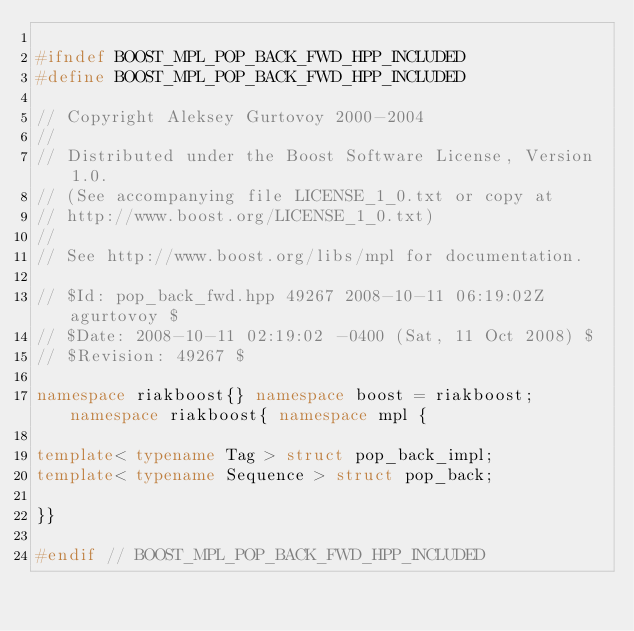Convert code to text. <code><loc_0><loc_0><loc_500><loc_500><_C++_>
#ifndef BOOST_MPL_POP_BACK_FWD_HPP_INCLUDED
#define BOOST_MPL_POP_BACK_FWD_HPP_INCLUDED

// Copyright Aleksey Gurtovoy 2000-2004
//
// Distributed under the Boost Software License, Version 1.0. 
// (See accompanying file LICENSE_1_0.txt or copy at 
// http://www.boost.org/LICENSE_1_0.txt)
//
// See http://www.boost.org/libs/mpl for documentation.

// $Id: pop_back_fwd.hpp 49267 2008-10-11 06:19:02Z agurtovoy $
// $Date: 2008-10-11 02:19:02 -0400 (Sat, 11 Oct 2008) $
// $Revision: 49267 $

namespace riakboost{} namespace boost = riakboost; namespace riakboost{ namespace mpl {

template< typename Tag > struct pop_back_impl;
template< typename Sequence > struct pop_back;

}}

#endif // BOOST_MPL_POP_BACK_FWD_HPP_INCLUDED
</code> 